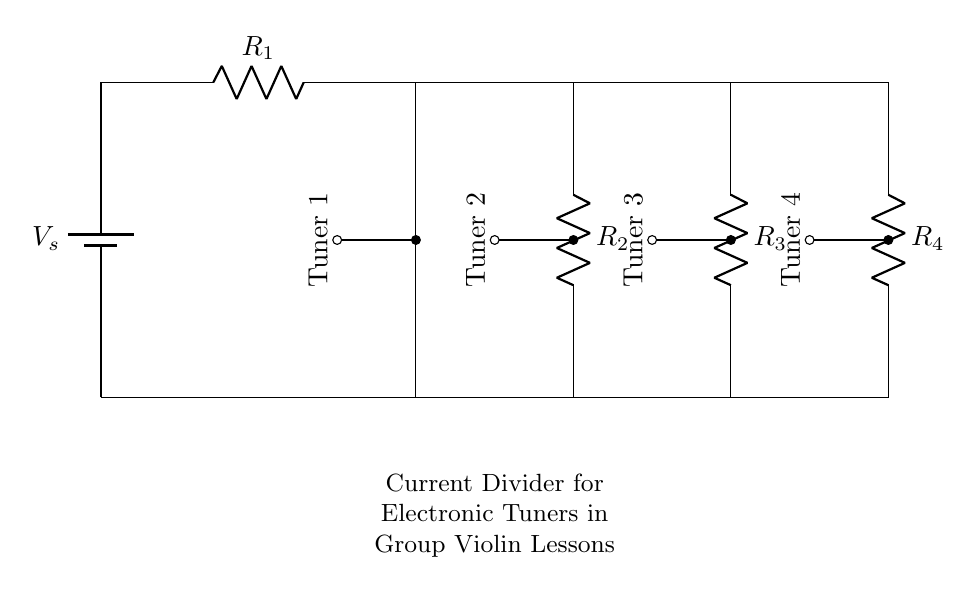What is the number of electronic tuners in the circuit? The circuit contains four electronic tuners connected in parallel. This can be observed from the four nodes labeled "Tuner 1," "Tuner 2," "Tuner 3," and "Tuner 4" branching from the same power source.
Answer: Four What type of circuit is this? This is a current divider circuit. A current divider circuit distributes the total current to multiple paths based on the resistance values, allowing each component, in this case, electronic tuners, to operate correctly with the shared power supply.
Answer: Current divider What is the total resistance in this circuit? In a current divider, the total resistance can be determined by the parallel resistances. However, the exact values of the resistors are not given in the diagram, so the total resistance would depend on R1, R2, R3, and R4, which are unknown variables.
Answer: Unknown Which tuner is connected to the largest resistor? From the circuit, the resistances R1, R2, R3, and R4 are not labeled with specific resistance values, making it impossible to determine conclusively which tuner corresponds to the largest resistor. Without explicit values, it cannot be answered.
Answer: Unknown How does changing the value of R4 affect the current through Tuner 4? As R4 increases, the current through Tuner 4 decreases, following the current divider rule. A higher resistance results in less current being shared with that path because the total current is divided among all resistors inversely proportional to their resistance values.
Answer: Decreases If the supply voltage is 9 volts, what is the voltage across each tuner? In a current divider, if the supply voltage is uniform across the resistors, the voltage across each tuner is the same as the supply voltage. Therefore, each tuner gets the full supply voltage because they are connected in parallel.
Answer: Nine volts What happens to the total current when R1 is decreased? When R1 is decreased, the total current of the circuit increases because the equivalent resistance of the circuit decreases. According to Ohm's law, a lower resistance leads to higher current when the voltage remains constant.
Answer: Increases 